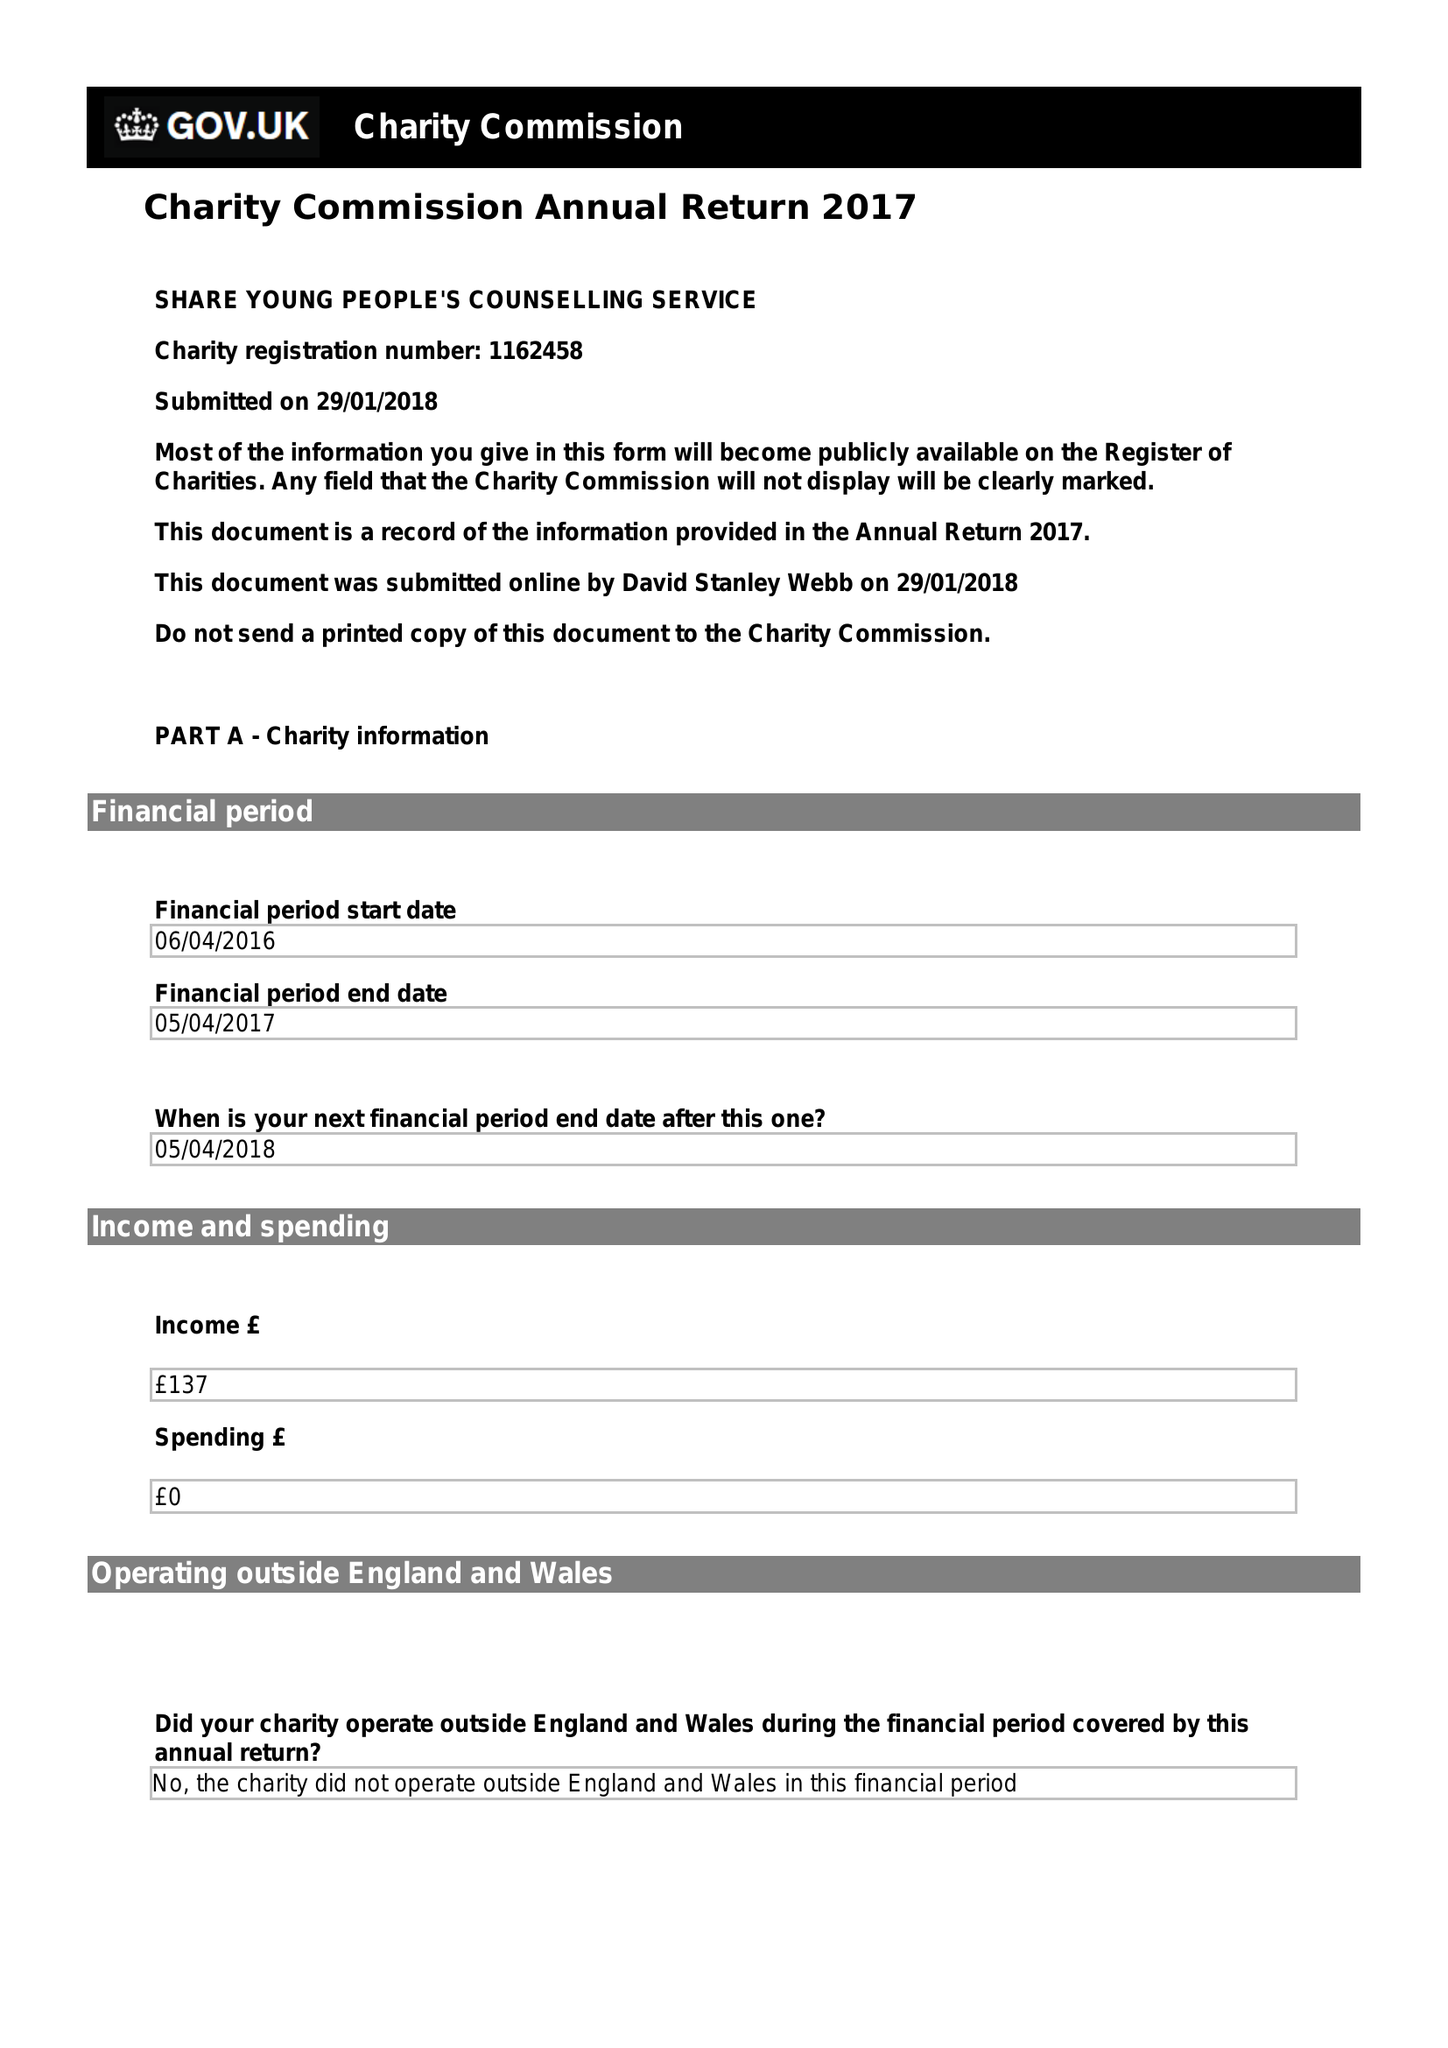What is the value for the address__postcode?
Answer the question using a single word or phrase. GL52 5QJ 